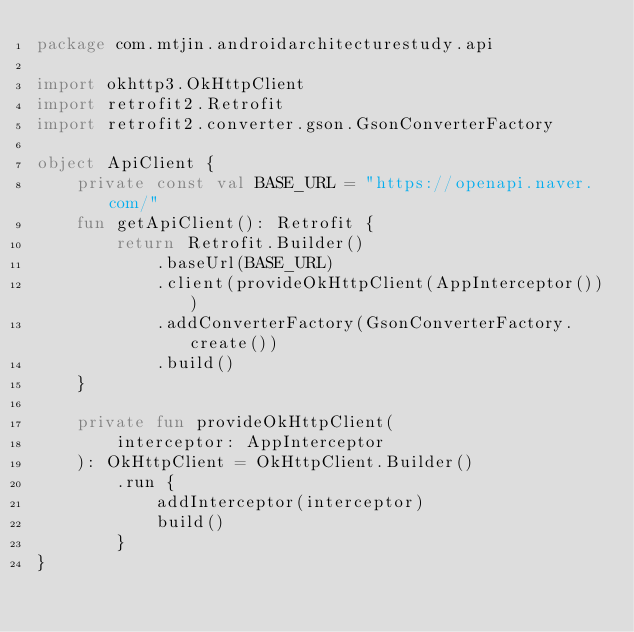<code> <loc_0><loc_0><loc_500><loc_500><_Kotlin_>package com.mtjin.androidarchitecturestudy.api

import okhttp3.OkHttpClient
import retrofit2.Retrofit
import retrofit2.converter.gson.GsonConverterFactory

object ApiClient {
    private const val BASE_URL = "https://openapi.naver.com/"
    fun getApiClient(): Retrofit {
        return Retrofit.Builder()
            .baseUrl(BASE_URL)
            .client(provideOkHttpClient(AppInterceptor()))
            .addConverterFactory(GsonConverterFactory.create())
            .build()
    }

    private fun provideOkHttpClient(
        interceptor: AppInterceptor
    ): OkHttpClient = OkHttpClient.Builder()
        .run {
            addInterceptor(interceptor)
            build()
        }
}</code> 